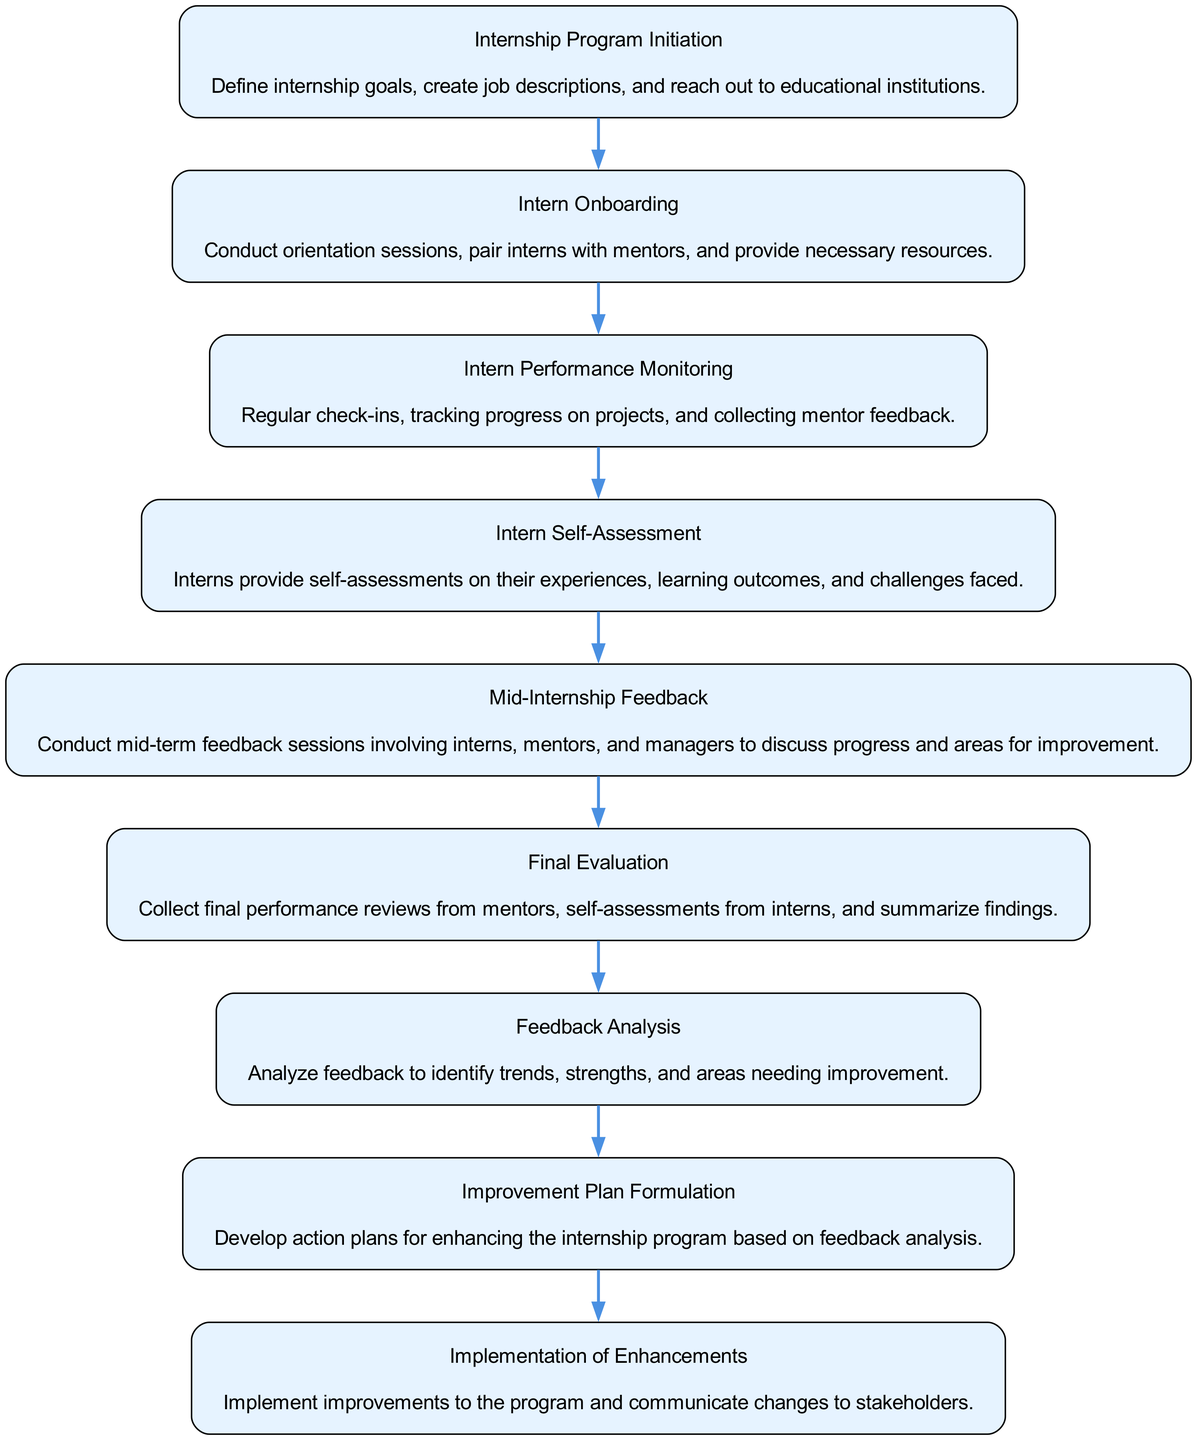What is the first step in the internship feedback process? The first step in the process is "Internship Program Initiation," which involves defining goals and reaching out to educational institutions.
Answer: Internship Program Initiation How many nodes are in the diagram? To find the number of nodes, count each element listed in the elements array of the provided data. There are nine elements in total.
Answer: Nine What is the last step in the process? The last step, as indicated in the diagram, is "Implementation of Enhancements."
Answer: Implementation of Enhancements Which step follows "Final Evaluation"? The step that follows "Final Evaluation" is "Feedback Analysis," as it is the next node in the flow of the diagram.
Answer: Feedback Analysis How many feedback sessions are conducted throughout the diagram? In the diagram, two feedback sessions are mentioned: the "Mid-Internship Feedback" and the feedback collection during the "Final Evaluation."
Answer: Two What is the purpose of "Intern Self-Assessment"? The purpose of "Intern Self-Assessment" is to allow interns to provide their perspectives on experiences, learning outcomes, and challenges during their internship.
Answer: Provide self-assessments What is the relationship between "Feedback Analysis" and "Improvement Plan Formulation"? "Feedback Analysis" feeds directly into "Improvement Plan Formulation," indicating that insights from analyzing feedback are used to formulate improvements.
Answer: Direct relationship Name one key action taken during "Intern Onboarding." One key action during "Intern Onboarding" is conducting orientation sessions for the interns to introduce them to the program and its expectations.
Answer: Conduct orientation sessions What step includes both interns and managers? The "Mid-Internship Feedback" step includes both interns and managers, as it involves discussions about progress and areas for improvement.
Answer: Mid-Internship Feedback 